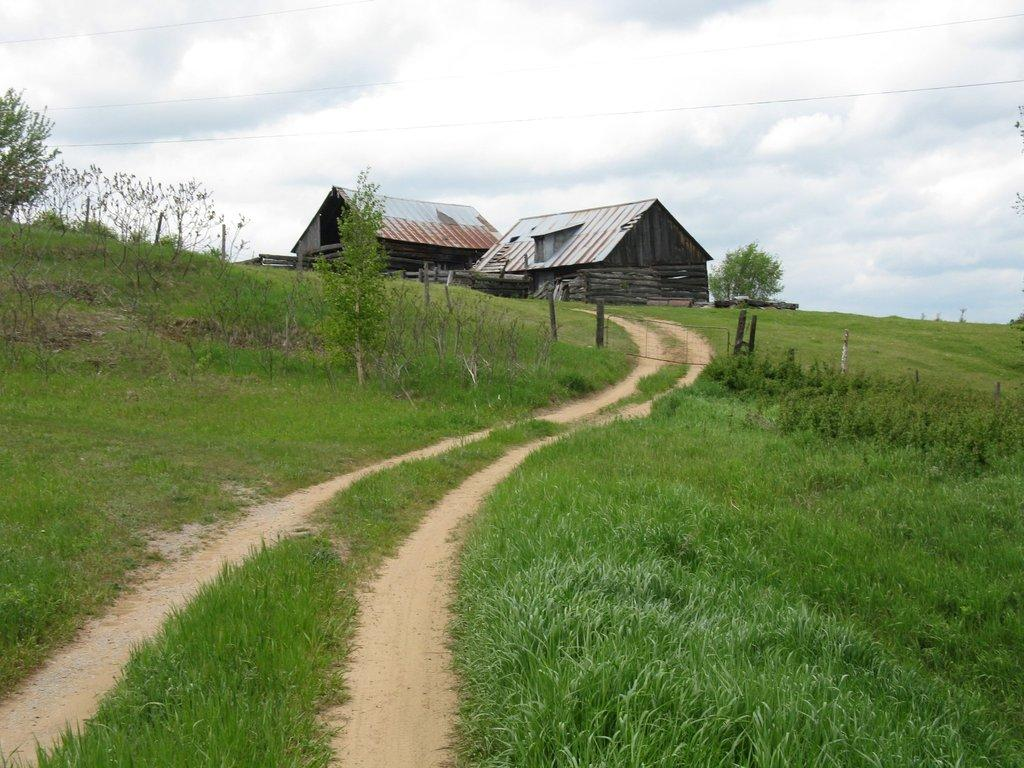What type of vegetation can be seen in the image? There is grass, plants, and trees in the image. What type of structures are present in the image? There are sheds in the image. What is visible in the background of the image? The sky is visible in the background of the image. What can be seen in the sky? There are clouds in the sky. What news is being discussed by the trees in the image? There are no trees discussing news in the image; the trees are simply part of the natural landscape. 